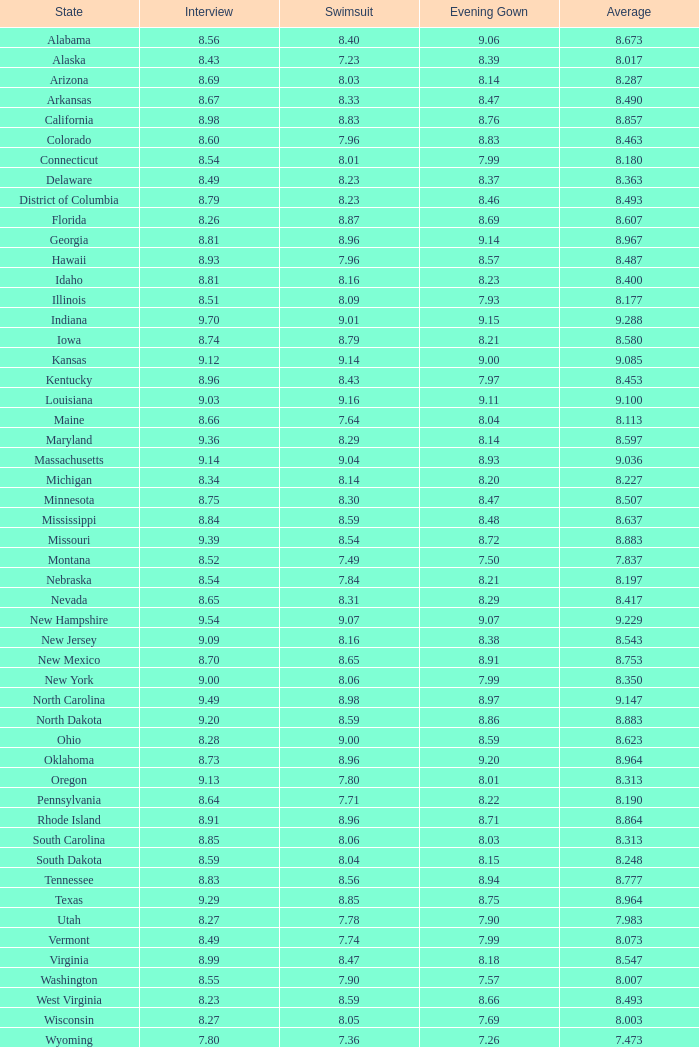Determine the count of interviews related to evening gowns that have a sum greater than 8.37 and an average rating of 8.363. None. 